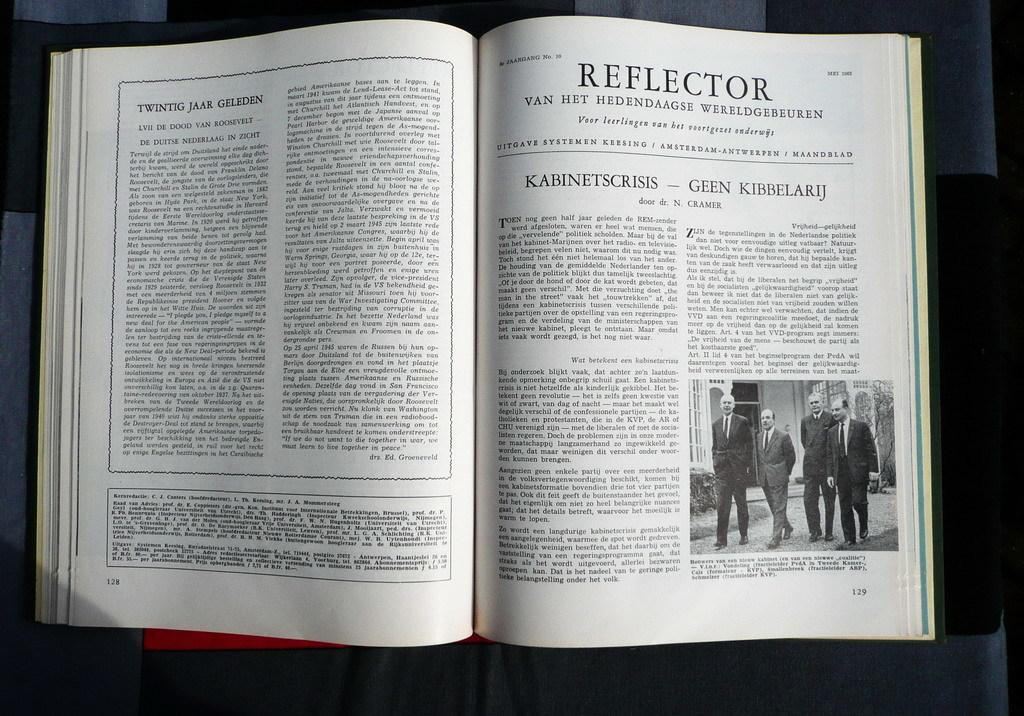Provide a one-sentence caption for the provided image. A book is open to page 128 with an article titled "Twintig Jaar Geleden" and page 129 which is titled "Reflector". 